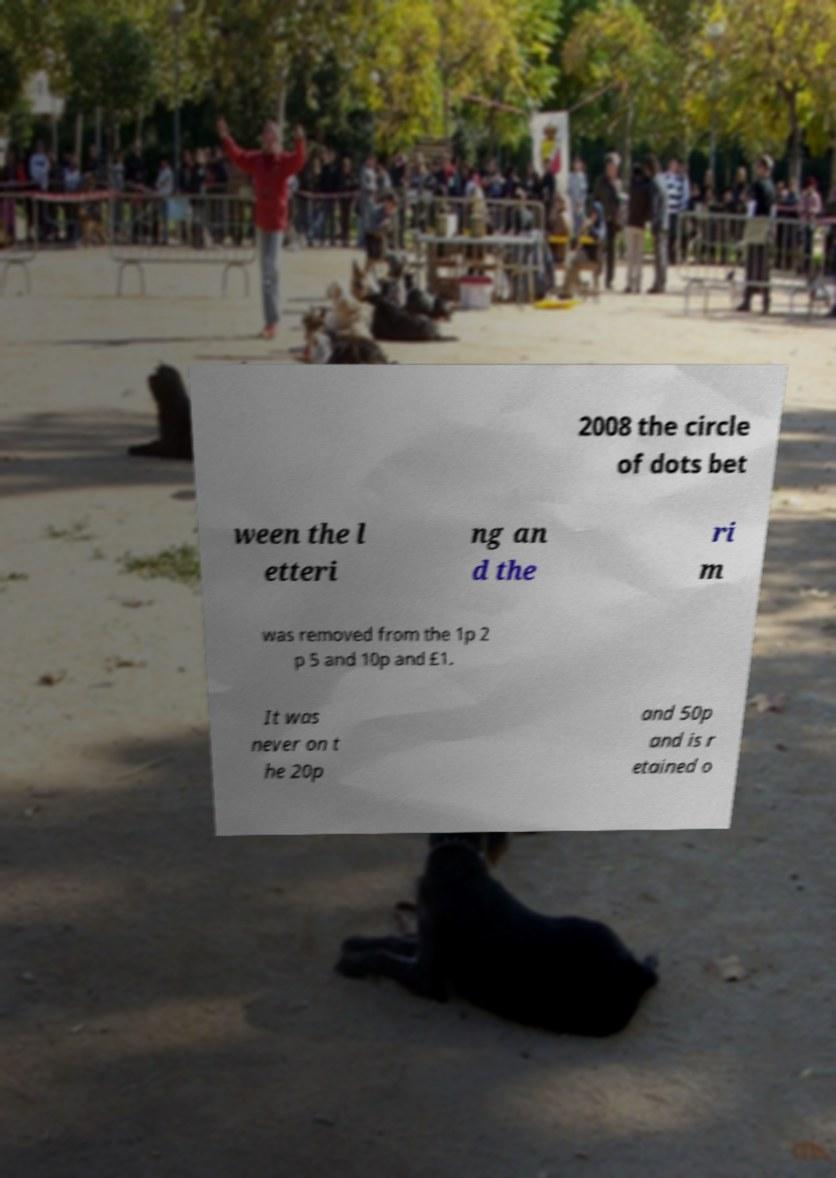Please read and relay the text visible in this image. What does it say? 2008 the circle of dots bet ween the l etteri ng an d the ri m was removed from the 1p 2 p 5 and 10p and £1. It was never on t he 20p and 50p and is r etained o 